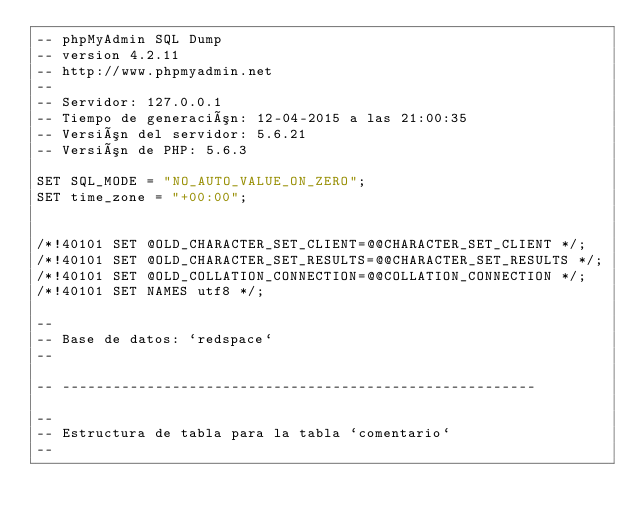Convert code to text. <code><loc_0><loc_0><loc_500><loc_500><_SQL_>-- phpMyAdmin SQL Dump
-- version 4.2.11
-- http://www.phpmyadmin.net
--
-- Servidor: 127.0.0.1
-- Tiempo de generación: 12-04-2015 a las 21:00:35
-- Versión del servidor: 5.6.21
-- Versión de PHP: 5.6.3

SET SQL_MODE = "NO_AUTO_VALUE_ON_ZERO";
SET time_zone = "+00:00";


/*!40101 SET @OLD_CHARACTER_SET_CLIENT=@@CHARACTER_SET_CLIENT */;
/*!40101 SET @OLD_CHARACTER_SET_RESULTS=@@CHARACTER_SET_RESULTS */;
/*!40101 SET @OLD_COLLATION_CONNECTION=@@COLLATION_CONNECTION */;
/*!40101 SET NAMES utf8 */;

--
-- Base de datos: `redspace`
--

-- --------------------------------------------------------

--
-- Estructura de tabla para la tabla `comentario`
--
</code> 